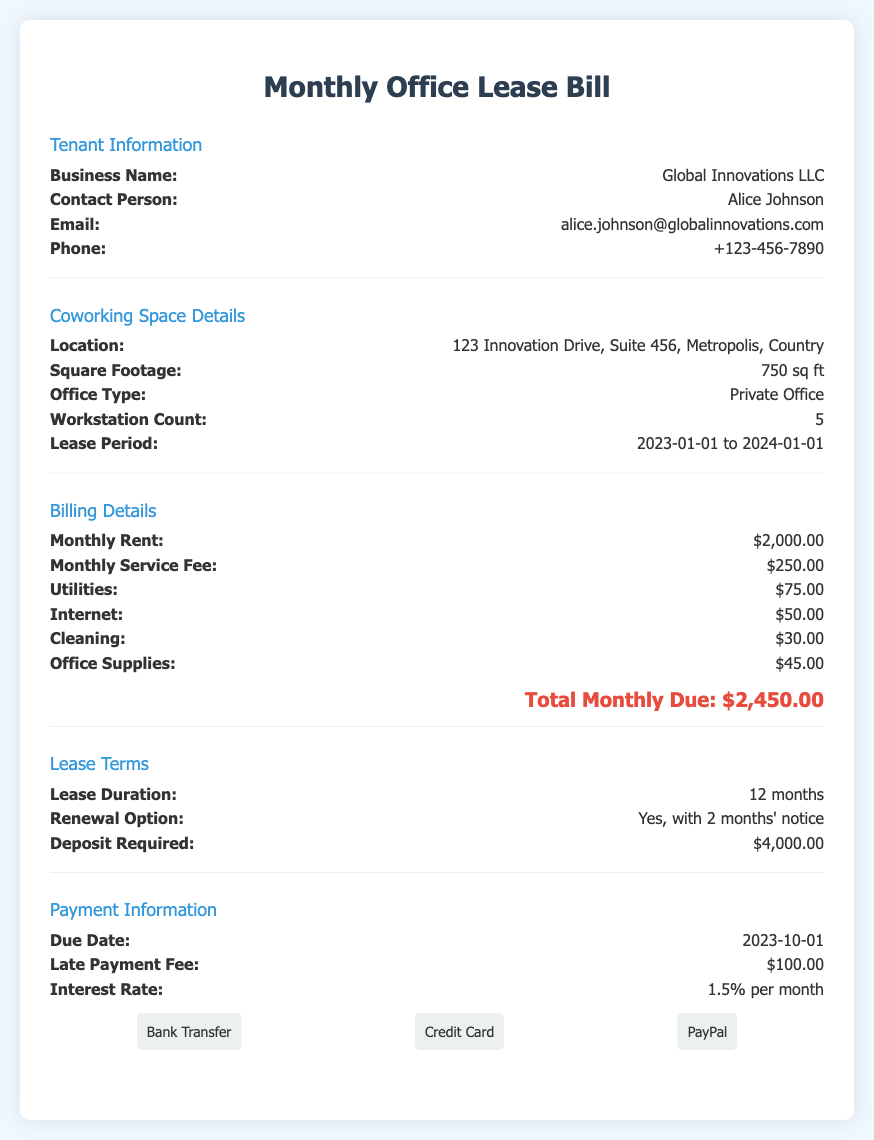What is the tenant's business name? The tenant's business name is listed in the document, specifically under Tenant Information.
Answer: Global Innovations LLC What is the total monthly due? The total monthly due is provided in the Billing Details section at the document's end.
Answer: $2,450.00 What is the square footage of the office? The square footage is mentioned in the Coworking Space Details section.
Answer: 750 sq ft What is the lease period? The lease period is specified in the Coworking Space Details section and states the starting and ending dates.
Answer: 2023-01-01 to 2024-01-01 What is the required deposit for the lease? The document states the deposit required in the Lease Terms section.
Answer: $4,000.00 How much is the late payment fee? The late payment fee is recorded in the Payment Information section of the document.
Answer: $100.00 Is there a renewal option for the lease? The lease terms indicate whether there is an option to renew the lease, which is relevant information.
Answer: Yes, with 2 months' notice What is the due date for the payment? The due date for the payment can be found in the Payment Information section.
Answer: 2023-10-01 How many workstations are in the office? The number of workstations is mentioned in the Coworking Space Details section.
Answer: 5 